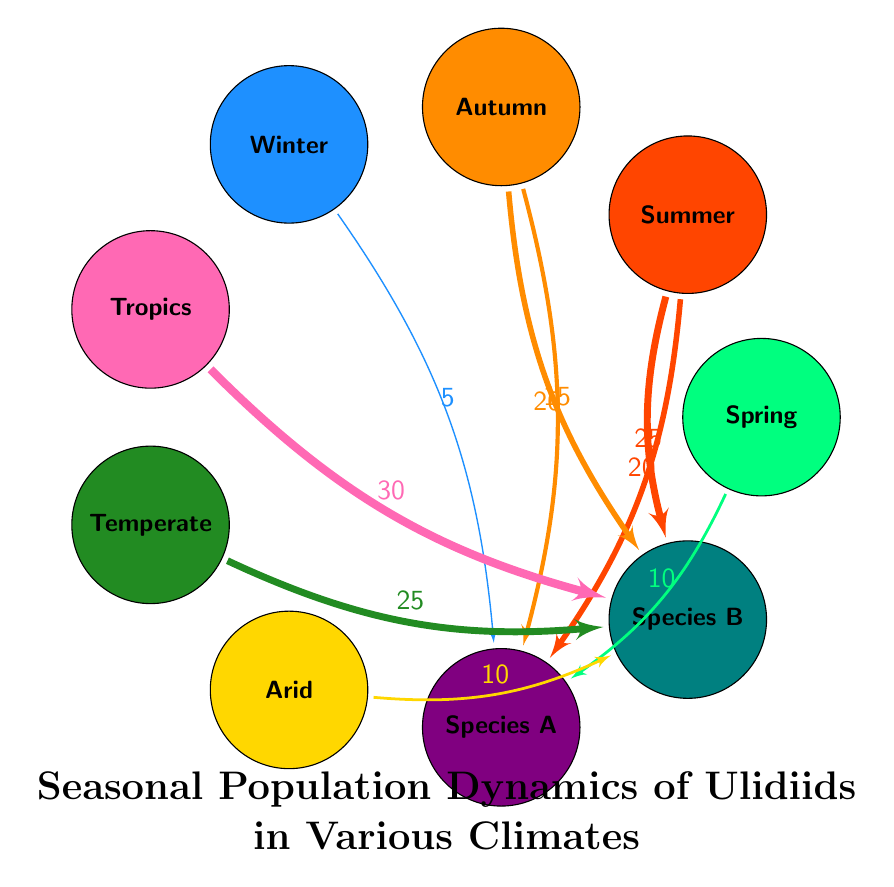What is the value of the link from Summer to Ulidiidae Species A? The link from Summer to Ulidiidae Species A indicates a value of 20 in the diagram, which is shown next to the connecting line from the Summer node to the Species A node.
Answer: 20 What is the season with the highest population for Ulidiidae Species B? The link from Tropics to Ulidiidae Species B has the highest value of 30, making it the season with the highest population for this species.
Answer: Tropics How many species of Ulidiidae are depicted in the diagram? The diagram shows two species of Ulidiidae, labeled as Species A and Species B, making the total count two.
Answer: 2 Which climate has the second-highest link value associated with Ulidiidae Species B? The link from Temperate to Ulidiidae Species B has a value of 25, which is the second-largest after the Tropics (30), thus representing the second-highest link value associated with Species B.
Answer: Temperate What is the total population of Ulidiidae Species A across all seasons? To find the total population of Species A, we add the values of the links: 10 (Spring) + 20 (Summer) + 15 (Autumn) + 5 (Winter) = 50. Therefore, the total population of Species A across all seasons is 50.
Answer: 50 Which season has the lowest population for Ulidiidae Species A? The link from Winter to Ulidiidae Species A has the lowest value, which is 5, indicating that Winter has the lowest population for this species.
Answer: Winter In which two climates does Ulidiidae Species B have populations during the Autumn? The links from Autumn to both Ulidiidae Species A and Species B indicate values, but the specific link for Species B holds a value of 20; therefore, the two climates where Species B populations are present in Autumn are Tropics and Temperate.
Answer: Tropics, Temperate What is the difference in population from Summer to Autumn for Ulidiidae Species B? From the diagram, there is a link from Summer to Ulidiidae Species B with a value of 25, and from Autumn to Ulidiidae Species B with a value of 20. Hence, the population difference is 25 - 20 = 5.
Answer: 5 Which Ulidiidae species has a population presence in all four seasons? The population presence is indicated by links: Ulidiidae Species A appears in Spring, Summer, Autumn, and Winter, confirming it has a presence in all four seasons.
Answer: Species A What is the primary color representing Winter in this diagram? The primary color representing Winter in this diagram is blue, specifically a shade of blue distinguished by the designated color code for the Winter node.
Answer: Blue 